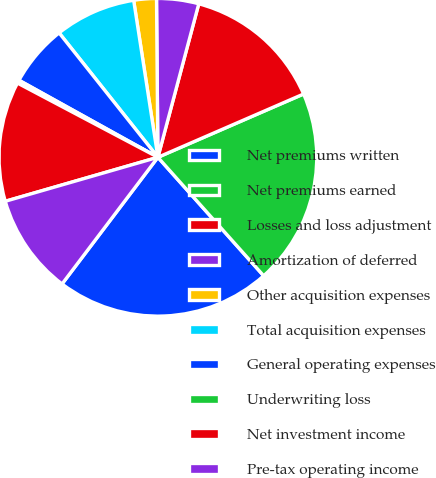Convert chart. <chart><loc_0><loc_0><loc_500><loc_500><pie_chart><fcel>Net premiums written<fcel>Net premiums earned<fcel>Losses and loss adjustment<fcel>Amortization of deferred<fcel>Other acquisition expenses<fcel>Total acquisition expenses<fcel>General operating expenses<fcel>Underwriting loss<fcel>Net investment income<fcel>Pre-tax operating income<nl><fcel>21.9%<fcel>19.92%<fcel>14.33%<fcel>4.28%<fcel>2.3%<fcel>8.24%<fcel>6.26%<fcel>0.32%<fcel>12.2%<fcel>10.22%<nl></chart> 